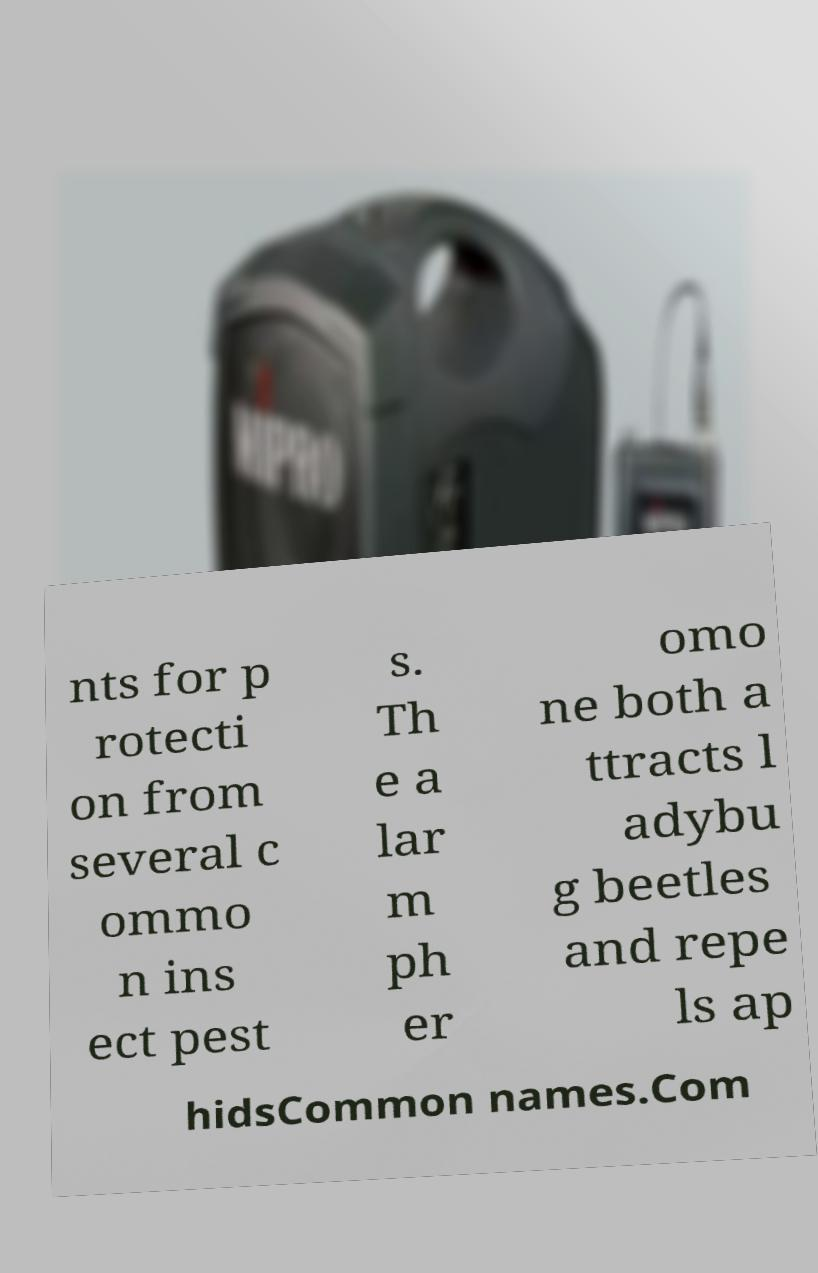What messages or text are displayed in this image? I need them in a readable, typed format. nts for p rotecti on from several c ommo n ins ect pest s. Th e a lar m ph er omo ne both a ttracts l adybu g beetles and repe ls ap hidsCommon names.Com 